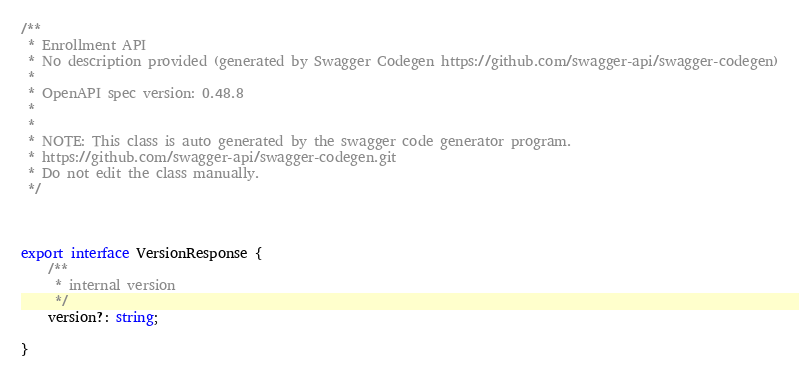<code> <loc_0><loc_0><loc_500><loc_500><_TypeScript_>/**
 * Enrollment API
 * No description provided (generated by Swagger Codegen https://github.com/swagger-api/swagger-codegen)
 *
 * OpenAPI spec version: 0.48.8
 * 
 *
 * NOTE: This class is auto generated by the swagger code generator program.
 * https://github.com/swagger-api/swagger-codegen.git
 * Do not edit the class manually.
 */



export interface VersionResponse {
    /**
     * internal version
     */
    version?: string;

}


</code> 